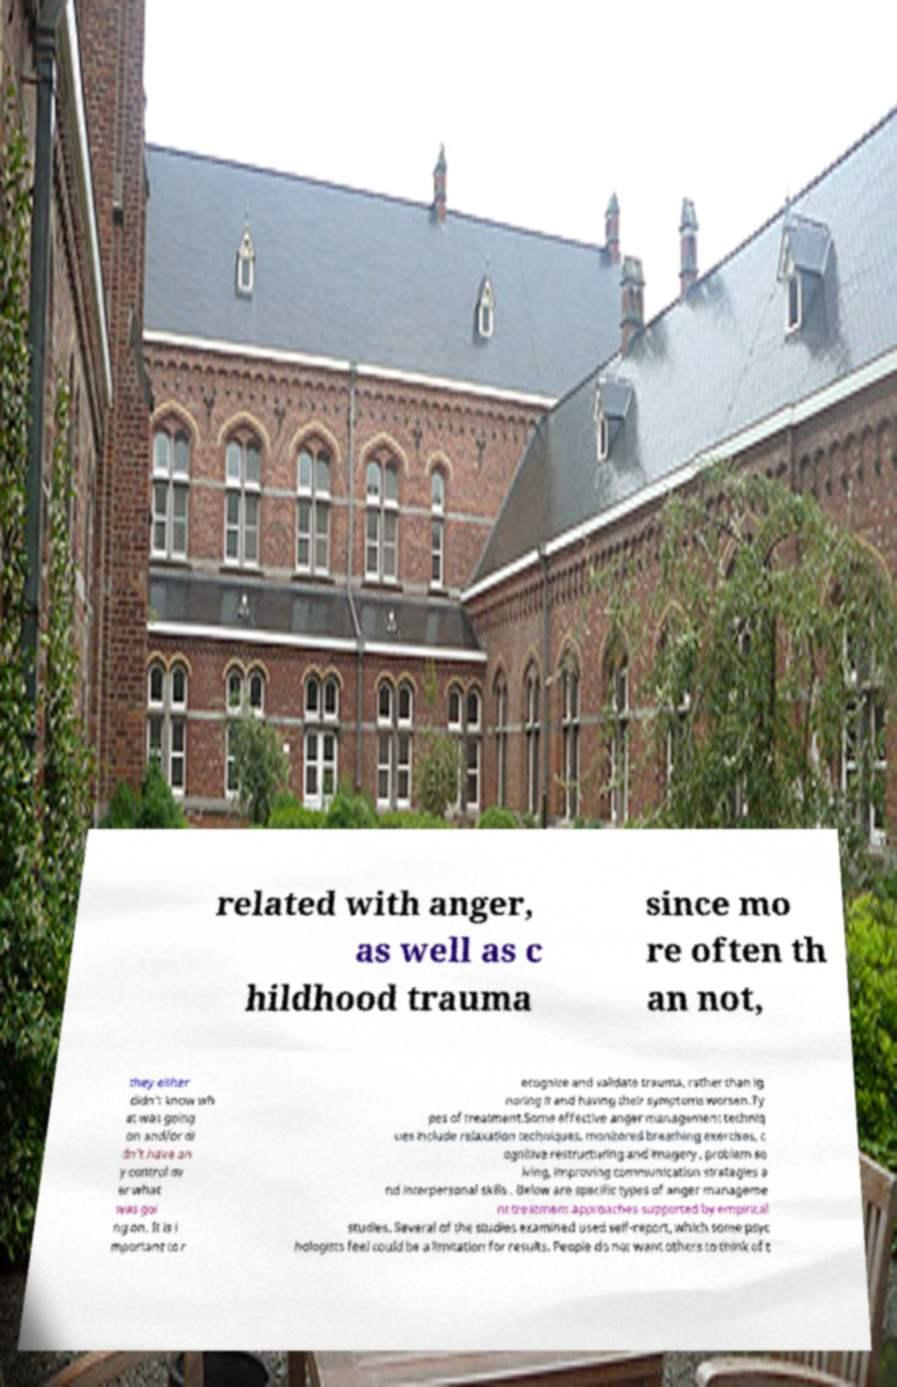Could you assist in decoding the text presented in this image and type it out clearly? related with anger, as well as c hildhood trauma since mo re often th an not, they either didn’t know wh at was going on and/or di dn’t have an y control ov er what was goi ng on. It is i mportant to r ecognize and validate trauma, rather than ig noring it and having their symptoms worsen.Ty pes of treatment.Some effective anger management techniq ues include relaxation techniques, monitored breathing exercises, c ognitive restructuring and imagery , problem so lving, improving communication strategies a nd interpersonal skills . Below are specific types of anger manageme nt treatment approaches supported by empirical studies. Several of the studies examined used self-report, which some psyc hologists feel could be a limitation for results. People do not want others to think of t 